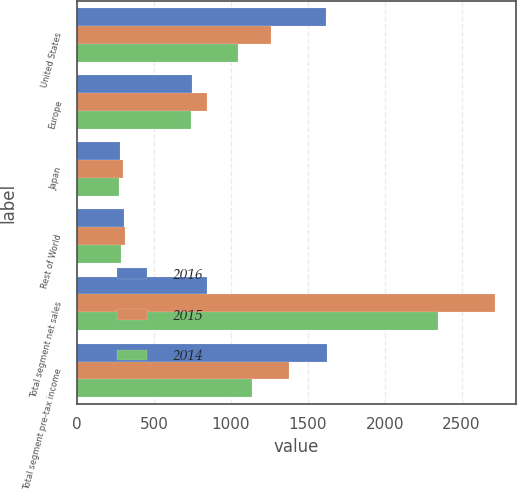Convert chart. <chart><loc_0><loc_0><loc_500><loc_500><stacked_bar_chart><ecel><fcel>United States<fcel>Europe<fcel>Japan<fcel>Rest of World<fcel>Total segment net sales<fcel>Total segment pre-tax income<nl><fcel>2016<fcel>1615.7<fcel>745.9<fcel>279.6<fcel>303.6<fcel>842.9<fcel>1623.7<nl><fcel>2015<fcel>1262.8<fcel>842.9<fcel>297.2<fcel>315.1<fcel>2718<fcel>1378.5<nl><fcel>2014<fcel>1047.3<fcel>741.4<fcel>270.8<fcel>285.1<fcel>2344.6<fcel>1137.5<nl></chart> 